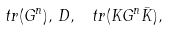Convert formula to latex. <formula><loc_0><loc_0><loc_500><loc_500>\ t r ( G ^ { n } ) , \, { D } , \, \ t r ( { K } G ^ { n } \bar { K } ) ,</formula> 